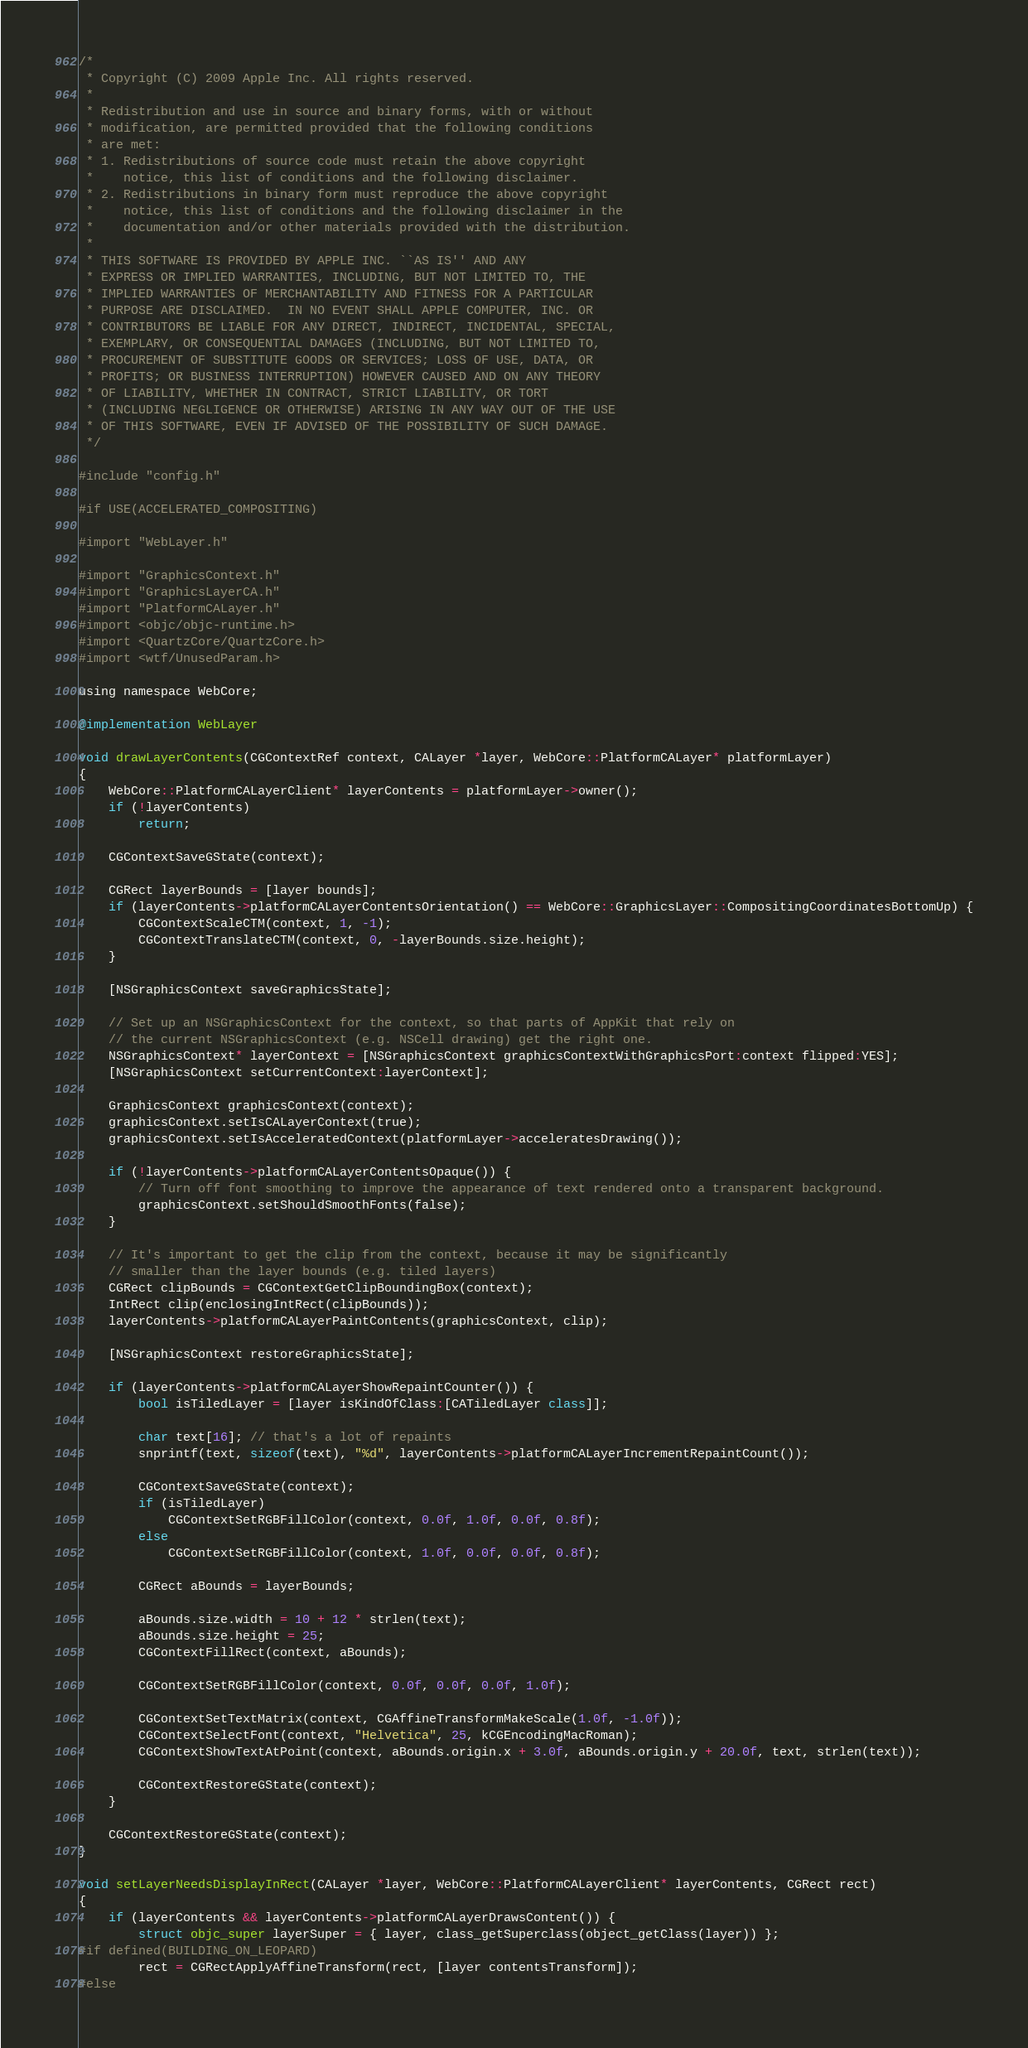<code> <loc_0><loc_0><loc_500><loc_500><_ObjectiveC_>/*
 * Copyright (C) 2009 Apple Inc. All rights reserved.
 *
 * Redistribution and use in source and binary forms, with or without
 * modification, are permitted provided that the following conditions
 * are met:
 * 1. Redistributions of source code must retain the above copyright
 *    notice, this list of conditions and the following disclaimer.
 * 2. Redistributions in binary form must reproduce the above copyright
 *    notice, this list of conditions and the following disclaimer in the
 *    documentation and/or other materials provided with the distribution.
 *
 * THIS SOFTWARE IS PROVIDED BY APPLE INC. ``AS IS'' AND ANY
 * EXPRESS OR IMPLIED WARRANTIES, INCLUDING, BUT NOT LIMITED TO, THE
 * IMPLIED WARRANTIES OF MERCHANTABILITY AND FITNESS FOR A PARTICULAR
 * PURPOSE ARE DISCLAIMED.  IN NO EVENT SHALL APPLE COMPUTER, INC. OR
 * CONTRIBUTORS BE LIABLE FOR ANY DIRECT, INDIRECT, INCIDENTAL, SPECIAL,
 * EXEMPLARY, OR CONSEQUENTIAL DAMAGES (INCLUDING, BUT NOT LIMITED TO,
 * PROCUREMENT OF SUBSTITUTE GOODS OR SERVICES; LOSS OF USE, DATA, OR
 * PROFITS; OR BUSINESS INTERRUPTION) HOWEVER CAUSED AND ON ANY THEORY
 * OF LIABILITY, WHETHER IN CONTRACT, STRICT LIABILITY, OR TORT
 * (INCLUDING NEGLIGENCE OR OTHERWISE) ARISING IN ANY WAY OUT OF THE USE
 * OF THIS SOFTWARE, EVEN IF ADVISED OF THE POSSIBILITY OF SUCH DAMAGE. 
 */

#include "config.h"

#if USE(ACCELERATED_COMPOSITING)

#import "WebLayer.h"

#import "GraphicsContext.h"
#import "GraphicsLayerCA.h"
#import "PlatformCALayer.h"
#import <objc/objc-runtime.h>
#import <QuartzCore/QuartzCore.h>
#import <wtf/UnusedParam.h>

using namespace WebCore;

@implementation WebLayer

void drawLayerContents(CGContextRef context, CALayer *layer, WebCore::PlatformCALayer* platformLayer)
{
    WebCore::PlatformCALayerClient* layerContents = platformLayer->owner();
    if (!layerContents)
        return;

    CGContextSaveGState(context);

    CGRect layerBounds = [layer bounds];
    if (layerContents->platformCALayerContentsOrientation() == WebCore::GraphicsLayer::CompositingCoordinatesBottomUp) {
        CGContextScaleCTM(context, 1, -1);
        CGContextTranslateCTM(context, 0, -layerBounds.size.height);
    }

    [NSGraphicsContext saveGraphicsState];

    // Set up an NSGraphicsContext for the context, so that parts of AppKit that rely on
    // the current NSGraphicsContext (e.g. NSCell drawing) get the right one.
    NSGraphicsContext* layerContext = [NSGraphicsContext graphicsContextWithGraphicsPort:context flipped:YES];
    [NSGraphicsContext setCurrentContext:layerContext];

    GraphicsContext graphicsContext(context);
    graphicsContext.setIsCALayerContext(true);
    graphicsContext.setIsAcceleratedContext(platformLayer->acceleratesDrawing());

    if (!layerContents->platformCALayerContentsOpaque()) {
        // Turn off font smoothing to improve the appearance of text rendered onto a transparent background.
        graphicsContext.setShouldSmoothFonts(false);
    }
    
    // It's important to get the clip from the context, because it may be significantly
    // smaller than the layer bounds (e.g. tiled layers)
    CGRect clipBounds = CGContextGetClipBoundingBox(context);
    IntRect clip(enclosingIntRect(clipBounds));
    layerContents->platformCALayerPaintContents(graphicsContext, clip);

    [NSGraphicsContext restoreGraphicsState];

    if (layerContents->platformCALayerShowRepaintCounter()) {
        bool isTiledLayer = [layer isKindOfClass:[CATiledLayer class]];

        char text[16]; // that's a lot of repaints
        snprintf(text, sizeof(text), "%d", layerContents->platformCALayerIncrementRepaintCount());

        CGContextSaveGState(context);
        if (isTiledLayer)
            CGContextSetRGBFillColor(context, 0.0f, 1.0f, 0.0f, 0.8f);
        else
            CGContextSetRGBFillColor(context, 1.0f, 0.0f, 0.0f, 0.8f);
        
        CGRect aBounds = layerBounds;

        aBounds.size.width = 10 + 12 * strlen(text);
        aBounds.size.height = 25;
        CGContextFillRect(context, aBounds);
        
        CGContextSetRGBFillColor(context, 0.0f, 0.0f, 0.0f, 1.0f);

        CGContextSetTextMatrix(context, CGAffineTransformMakeScale(1.0f, -1.0f));
        CGContextSelectFont(context, "Helvetica", 25, kCGEncodingMacRoman);
        CGContextShowTextAtPoint(context, aBounds.origin.x + 3.0f, aBounds.origin.y + 20.0f, text, strlen(text));
        
        CGContextRestoreGState(context);        
    }

    CGContextRestoreGState(context);
}

void setLayerNeedsDisplayInRect(CALayer *layer, WebCore::PlatformCALayerClient* layerContents, CGRect rect)
{
    if (layerContents && layerContents->platformCALayerDrawsContent()) {
        struct objc_super layerSuper = { layer, class_getSuperclass(object_getClass(layer)) };
#if defined(BUILDING_ON_LEOPARD)
        rect = CGRectApplyAffineTransform(rect, [layer contentsTransform]);
#else</code> 